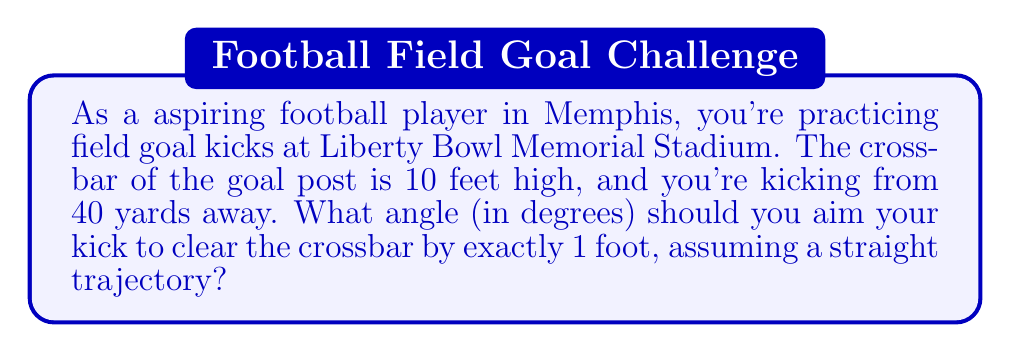Help me with this question. Let's approach this step-by-step using trigonometry:

1) First, let's visualize the problem:

[asy]
import geometry;

size(200);
pair A = (0,0), B = (120,0), C = (120,30), D = (120,33);
draw(A--B--C--A);
draw(B--D,dashed);
label("40 yards (120 ft)", (60,-5), S);
label("10 ft", (122,15), E);
label("1 ft", (122,31.5), E);
label("θ", (5,5), NW);
dot("Kicker", A, SW);
dot("Crossbar", C, SE);
dot("Target", D, NE);
[/asy]

2) We need to find the angle θ. We can use the tangent function, as we know the opposite and adjacent sides of the right triangle.

3) The opposite side is the height of the target (11 feet) minus the height of the ball when kicked (let's assume 3 feet off the ground).
   Opposite = 11 - 3 = 8 feet

4) The adjacent side is the distance to the goal post: 40 yards = 120 feet

5) Using the tangent function:

   $$\tan(\theta) = \frac{\text{opposite}}{\text{adjacent}} = \frac{8}{120} = \frac{1}{15}$$

6) To find θ, we need to use the inverse tangent (arctan or $\tan^{-1}$):

   $$\theta = \tan^{-1}(\frac{1}{15})$$

7) Using a calculator or computer:

   $$\theta \approx 3.814 \text{ degrees}$$

8) Rounding to the nearest tenth of a degree:

   $$\theta \approx 3.8 \text{ degrees}$$
Answer: $3.8°$ 